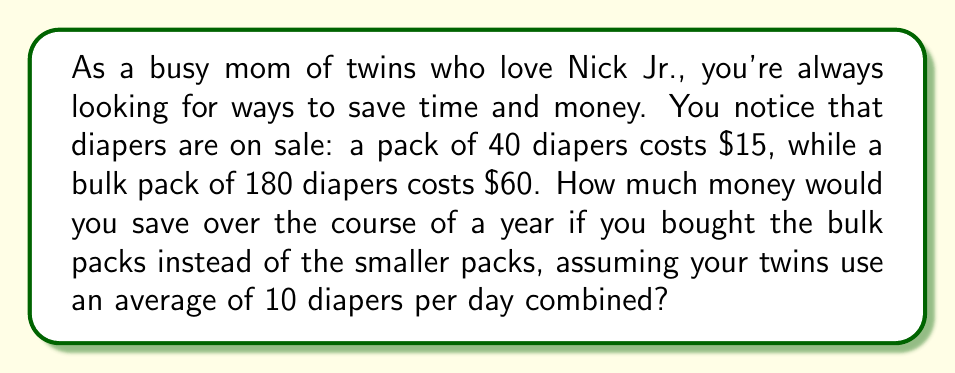Can you solve this math problem? Let's break this problem down step-by-step:

1. Calculate the cost per diaper for each pack size:
   - Small pack: $\frac{\$15}{40 \text{ diapers}} = \$0.375$ per diaper
   - Bulk pack: $\frac{\$60}{180 \text{ diapers}} = \$0.333$ per diaper (rounded to 3 decimal places)

2. Calculate the number of diapers used in a year:
   $10 \text{ diapers per day} \times 365 \text{ days} = 3,650 \text{ diapers per year}$

3. Calculate the cost for a year using small packs:
   $3,650 \text{ diapers} \times \$0.375 \text{ per diaper} = \$1,368.75$

4. Calculate the cost for a year using bulk packs:
   $3,650 \text{ diapers} \times \$0.333 \text{ per diaper} = \$1,215.45$

5. Calculate the savings:
   $\$1,368.75 - \$1,215.45 = \$153.30$

Therefore, by purchasing bulk packs instead of smaller packs, you would save $\$153.30$ over the course of a year.
Answer: $\$153.30$ 